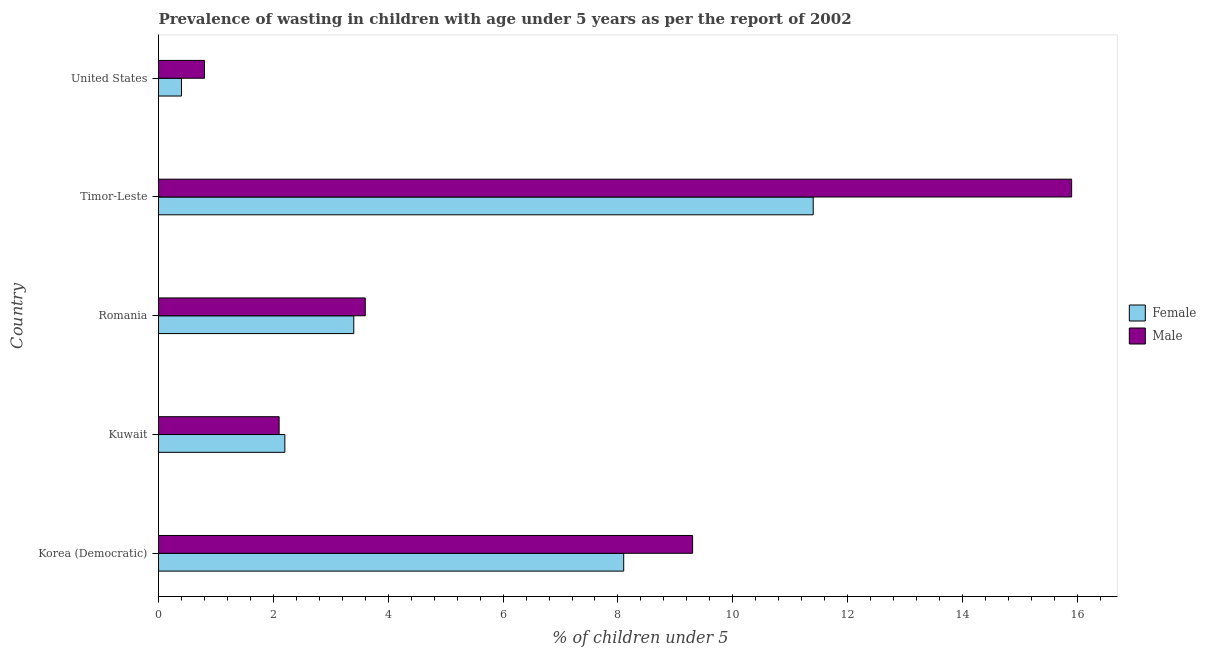How many bars are there on the 4th tick from the top?
Ensure brevity in your answer.  2. What is the label of the 1st group of bars from the top?
Keep it short and to the point. United States. What is the percentage of undernourished male children in Timor-Leste?
Offer a terse response. 15.9. Across all countries, what is the maximum percentage of undernourished female children?
Keep it short and to the point. 11.4. Across all countries, what is the minimum percentage of undernourished female children?
Offer a terse response. 0.4. In which country was the percentage of undernourished male children maximum?
Make the answer very short. Timor-Leste. In which country was the percentage of undernourished male children minimum?
Offer a terse response. United States. What is the total percentage of undernourished male children in the graph?
Provide a succinct answer. 31.7. What is the difference between the percentage of undernourished female children in Kuwait and the percentage of undernourished male children in Korea (Democratic)?
Make the answer very short. -7.1. What is the average percentage of undernourished male children per country?
Ensure brevity in your answer.  6.34. What is the difference between the percentage of undernourished female children and percentage of undernourished male children in Timor-Leste?
Your answer should be compact. -4.5. In how many countries, is the percentage of undernourished female children greater than 8.8 %?
Offer a terse response. 1. Is the percentage of undernourished male children in Kuwait less than that in United States?
Make the answer very short. No. What is the difference between the highest and the lowest percentage of undernourished male children?
Your answer should be compact. 15.1. Is the sum of the percentage of undernourished male children in Romania and United States greater than the maximum percentage of undernourished female children across all countries?
Your response must be concise. No. Are all the bars in the graph horizontal?
Your response must be concise. Yes. What is the difference between two consecutive major ticks on the X-axis?
Provide a succinct answer. 2. Are the values on the major ticks of X-axis written in scientific E-notation?
Provide a short and direct response. No. Does the graph contain grids?
Make the answer very short. No. Where does the legend appear in the graph?
Give a very brief answer. Center right. What is the title of the graph?
Provide a succinct answer. Prevalence of wasting in children with age under 5 years as per the report of 2002. Does "Arms imports" appear as one of the legend labels in the graph?
Offer a very short reply. No. What is the label or title of the X-axis?
Offer a terse response.  % of children under 5. What is the label or title of the Y-axis?
Give a very brief answer. Country. What is the  % of children under 5 in Female in Korea (Democratic)?
Ensure brevity in your answer.  8.1. What is the  % of children under 5 in Male in Korea (Democratic)?
Ensure brevity in your answer.  9.3. What is the  % of children under 5 in Female in Kuwait?
Offer a very short reply. 2.2. What is the  % of children under 5 in Male in Kuwait?
Offer a very short reply. 2.1. What is the  % of children under 5 of Female in Romania?
Give a very brief answer. 3.4. What is the  % of children under 5 of Male in Romania?
Your answer should be very brief. 3.6. What is the  % of children under 5 in Female in Timor-Leste?
Keep it short and to the point. 11.4. What is the  % of children under 5 of Male in Timor-Leste?
Ensure brevity in your answer.  15.9. What is the  % of children under 5 of Female in United States?
Provide a short and direct response. 0.4. What is the  % of children under 5 of Male in United States?
Provide a short and direct response. 0.8. Across all countries, what is the maximum  % of children under 5 of Female?
Offer a very short reply. 11.4. Across all countries, what is the maximum  % of children under 5 in Male?
Make the answer very short. 15.9. Across all countries, what is the minimum  % of children under 5 of Female?
Offer a terse response. 0.4. Across all countries, what is the minimum  % of children under 5 of Male?
Your answer should be compact. 0.8. What is the total  % of children under 5 in Male in the graph?
Your response must be concise. 31.7. What is the difference between the  % of children under 5 in Female in Korea (Democratic) and that in Kuwait?
Your answer should be very brief. 5.9. What is the difference between the  % of children under 5 in Male in Korea (Democratic) and that in Timor-Leste?
Ensure brevity in your answer.  -6.6. What is the difference between the  % of children under 5 in Female in Korea (Democratic) and that in United States?
Offer a terse response. 7.7. What is the difference between the  % of children under 5 in Male in Korea (Democratic) and that in United States?
Provide a short and direct response. 8.5. What is the difference between the  % of children under 5 of Female in Kuwait and that in Romania?
Make the answer very short. -1.2. What is the difference between the  % of children under 5 of Female in Kuwait and that in Timor-Leste?
Your answer should be compact. -9.2. What is the difference between the  % of children under 5 in Male in Kuwait and that in United States?
Give a very brief answer. 1.3. What is the difference between the  % of children under 5 of Male in Romania and that in Timor-Leste?
Make the answer very short. -12.3. What is the difference between the  % of children under 5 of Female in Romania and that in United States?
Offer a very short reply. 3. What is the difference between the  % of children under 5 of Male in Romania and that in United States?
Ensure brevity in your answer.  2.8. What is the difference between the  % of children under 5 in Female in Korea (Democratic) and the  % of children under 5 in Male in Kuwait?
Give a very brief answer. 6. What is the difference between the  % of children under 5 in Female in Korea (Democratic) and the  % of children under 5 in Male in Romania?
Offer a terse response. 4.5. What is the difference between the  % of children under 5 in Female in Korea (Democratic) and the  % of children under 5 in Male in United States?
Your answer should be compact. 7.3. What is the difference between the  % of children under 5 in Female in Kuwait and the  % of children under 5 in Male in Timor-Leste?
Keep it short and to the point. -13.7. What is the average  % of children under 5 of Female per country?
Your answer should be very brief. 5.1. What is the average  % of children under 5 in Male per country?
Give a very brief answer. 6.34. What is the difference between the  % of children under 5 of Female and  % of children under 5 of Male in Korea (Democratic)?
Your response must be concise. -1.2. What is the difference between the  % of children under 5 in Female and  % of children under 5 in Male in Kuwait?
Give a very brief answer. 0.1. What is the difference between the  % of children under 5 in Female and  % of children under 5 in Male in Romania?
Your answer should be compact. -0.2. What is the difference between the  % of children under 5 in Female and  % of children under 5 in Male in United States?
Your response must be concise. -0.4. What is the ratio of the  % of children under 5 of Female in Korea (Democratic) to that in Kuwait?
Provide a short and direct response. 3.68. What is the ratio of the  % of children under 5 of Male in Korea (Democratic) to that in Kuwait?
Your response must be concise. 4.43. What is the ratio of the  % of children under 5 of Female in Korea (Democratic) to that in Romania?
Provide a succinct answer. 2.38. What is the ratio of the  % of children under 5 of Male in Korea (Democratic) to that in Romania?
Offer a very short reply. 2.58. What is the ratio of the  % of children under 5 in Female in Korea (Democratic) to that in Timor-Leste?
Your answer should be very brief. 0.71. What is the ratio of the  % of children under 5 in Male in Korea (Democratic) to that in Timor-Leste?
Make the answer very short. 0.58. What is the ratio of the  % of children under 5 in Female in Korea (Democratic) to that in United States?
Ensure brevity in your answer.  20.25. What is the ratio of the  % of children under 5 in Male in Korea (Democratic) to that in United States?
Your answer should be very brief. 11.62. What is the ratio of the  % of children under 5 of Female in Kuwait to that in Romania?
Keep it short and to the point. 0.65. What is the ratio of the  % of children under 5 of Male in Kuwait to that in Romania?
Offer a terse response. 0.58. What is the ratio of the  % of children under 5 of Female in Kuwait to that in Timor-Leste?
Your response must be concise. 0.19. What is the ratio of the  % of children under 5 in Male in Kuwait to that in Timor-Leste?
Your response must be concise. 0.13. What is the ratio of the  % of children under 5 in Female in Kuwait to that in United States?
Give a very brief answer. 5.5. What is the ratio of the  % of children under 5 of Male in Kuwait to that in United States?
Your answer should be very brief. 2.62. What is the ratio of the  % of children under 5 of Female in Romania to that in Timor-Leste?
Your answer should be compact. 0.3. What is the ratio of the  % of children under 5 of Male in Romania to that in Timor-Leste?
Ensure brevity in your answer.  0.23. What is the ratio of the  % of children under 5 in Female in Romania to that in United States?
Keep it short and to the point. 8.5. What is the ratio of the  % of children under 5 in Male in Romania to that in United States?
Keep it short and to the point. 4.5. What is the ratio of the  % of children under 5 in Male in Timor-Leste to that in United States?
Your answer should be compact. 19.88. 